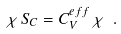<formula> <loc_0><loc_0><loc_500><loc_500>\chi \, \dot { S } _ { C } = C _ { V } ^ { e \, f \, f } \, \dot { \chi } \ .</formula> 